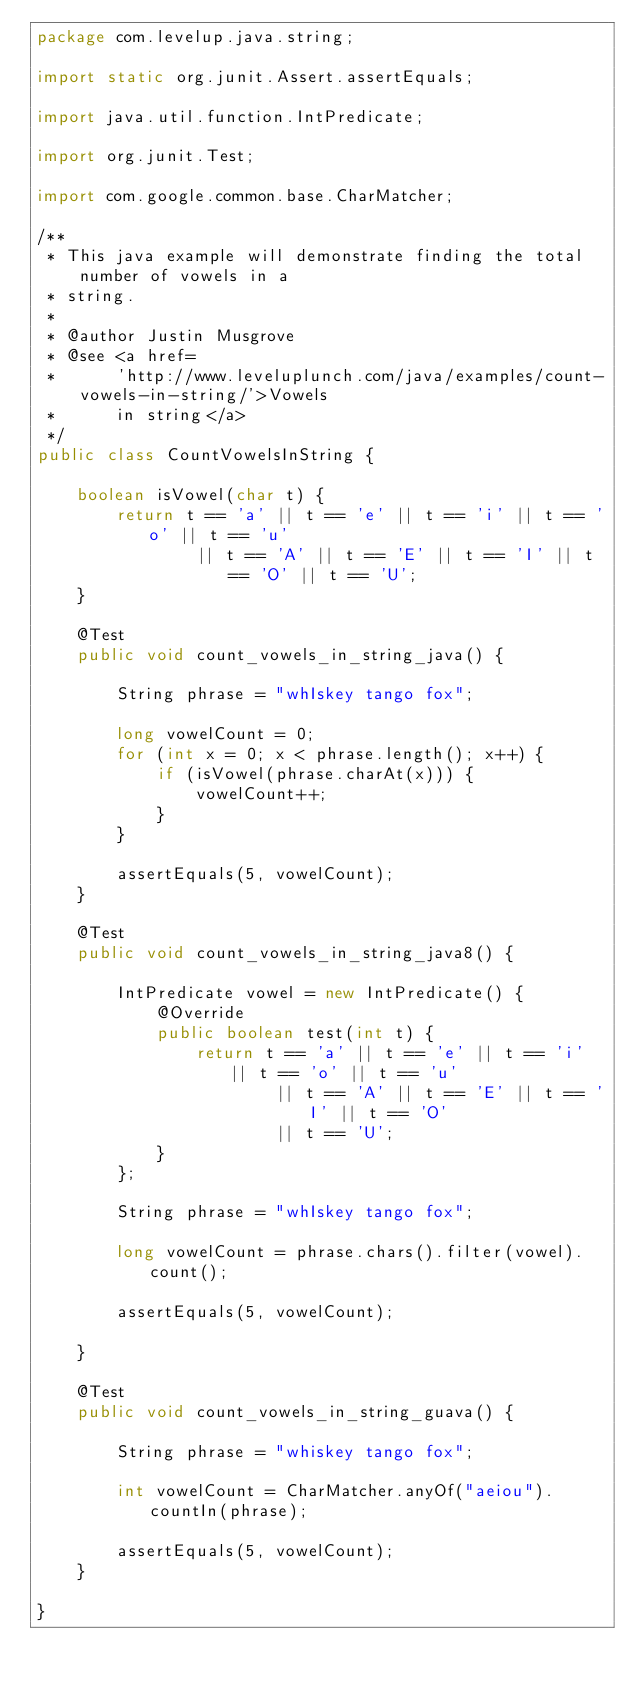Convert code to text. <code><loc_0><loc_0><loc_500><loc_500><_Java_>package com.levelup.java.string;

import static org.junit.Assert.assertEquals;

import java.util.function.IntPredicate;

import org.junit.Test;

import com.google.common.base.CharMatcher;

/**
 * This java example will demonstrate finding the total number of vowels in a
 * string.
 * 
 * @author Justin Musgrove
 * @see <a href=
 *      'http://www.leveluplunch.com/java/examples/count-vowels-in-string/'>Vowels
 *      in string</a>
 */
public class CountVowelsInString {

	boolean isVowel(char t) {
		return t == 'a' || t == 'e' || t == 'i' || t == 'o' || t == 'u'
				|| t == 'A' || t == 'E' || t == 'I' || t == 'O' || t == 'U';
	}

	@Test
	public void count_vowels_in_string_java() {

		String phrase = "whIskey tango fox";

		long vowelCount = 0;
		for (int x = 0; x < phrase.length(); x++) {
			if (isVowel(phrase.charAt(x))) {
				vowelCount++;
			}
		}

		assertEquals(5, vowelCount);
	}

	@Test
	public void count_vowels_in_string_java8() {

		IntPredicate vowel = new IntPredicate() {
			@Override
			public boolean test(int t) {
				return t == 'a' || t == 'e' || t == 'i' || t == 'o' || t == 'u'
						|| t == 'A' || t == 'E' || t == 'I' || t == 'O'
						|| t == 'U';
			}
		};

		String phrase = "whIskey tango fox";

		long vowelCount = phrase.chars().filter(vowel).count();

		assertEquals(5, vowelCount);

	}

	@Test
	public void count_vowels_in_string_guava() {

		String phrase = "whiskey tango fox";

		int vowelCount = CharMatcher.anyOf("aeiou").countIn(phrase);

		assertEquals(5, vowelCount);
	}

}
</code> 